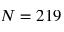<formula> <loc_0><loc_0><loc_500><loc_500>N = 2 1 9</formula> 